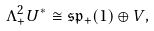Convert formula to latex. <formula><loc_0><loc_0><loc_500><loc_500>\Lambda ^ { 2 } _ { + } U ^ { * } \cong \mathfrak { s p } _ { + } ( 1 ) \oplus V ,</formula> 